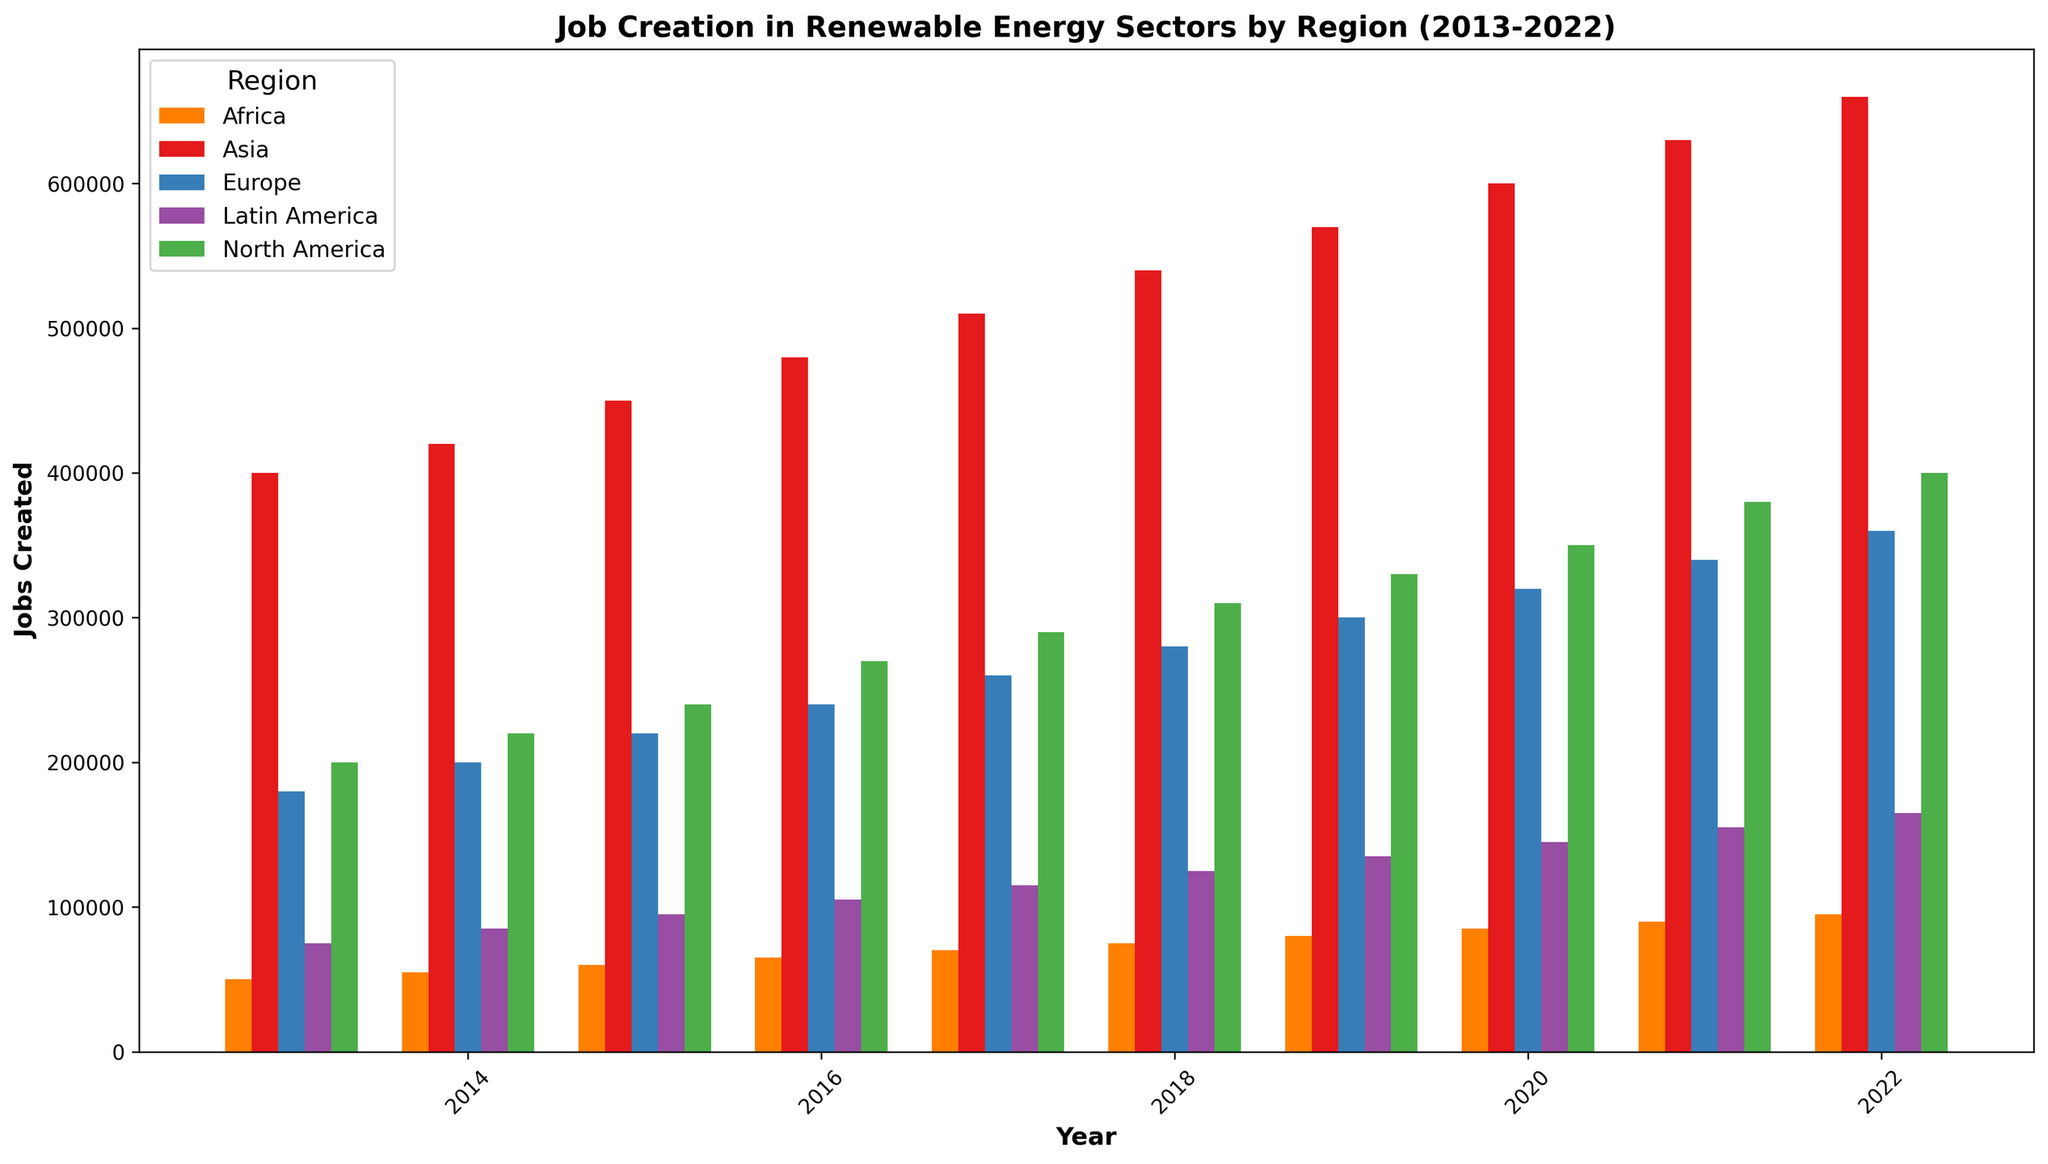What is the region with the highest number of jobs created in 2022? The figure shows job creation data for different regions, with each region represented by differently colored bars. Identify the tallest bar for the year 2022 to find the region with the highest job creation. The tallest bar in 2022 corresponds to Asia.
Answer: Asia Which region experienced the largest increase in job creation from 2013 to 2022? By comparing the heights of bars from 2013 to 2022 for each region, you can calculate the increase by subtracting the height of the 2013 bar from the height of the 2022 bar. Asia has the largest increase in job creation from 400,000 in 2013 to 660,000 in 2022, an increase of 260,000.
Answer: Asia How many more jobs were created in North America compared to Latin America in 2022? Look at the bars representing North America and Latin America in 2022. North America's bar reaches 400,000 jobs and Latin America's bar reaches 165,000 jobs. Subtract Latin America's job creation from North America's: 400,000 - 165,000 = 235,000 more jobs in North America.
Answer: 235,000 Rank the regions based on the number of jobs created in 2017 from highest to lowest. For the year 2017, check the heights of the bars for each region. Asia has the highest jobs (510,000), followed by North America (290,000), Europe (260,000), Latin America (115,000), and Africa (70,000). So, the ranking is Asia, North America, Europe, Latin America, Africa.
Answer: Asia, North America, Europe, Latin America, Africa What is the average number of jobs created in Europe from 2013 to 2022? To determine the average, sum the job creation numbers for Europe over the years 2013 to 2022 and then divide by the number of years. Summing all the values gives (180000 + 200000 + 220000 + 240000 + 260000 + 280000 + 300000 + 320000 + 340000 + 360000) = 2700000. Dividing by the 10 years gives an average of 2700000 / 10 = 270,000.
Answer: 270,000 Which year shows the smallest difference in job creation between North America and Europe? Calculate the differences in job creation between North America and Europe for each year by subtracting Europe’s job creation numbers from North America's. The year with the smallest absolute difference is 2013 with North America at 200,000 and Europe at 180,000:
Answer: 2013 Among all the regions, which one shows the least number of jobs created in 2015? Look at the bars for the year 2015 for all regions and identify the shortest one. Africa's bar for 2015 is the shortest, showing 60,000 jobs created.
Answer: Africa How does the job creation trend in Africa from 2013 to 2022 compare to that in Asia? Observe the length of bars representing Africa and Asia from 2013 to 2022. While both regions show an upward trend, Asia's increase is substantially larger (from 400,000 to 660,000) compared to Africa's steady yet smaller increase (from 50,000 to 95,000).
Answer: Asia shows a significantly larger increase What is the total number of jobs created across all regions in 2020? Sum the bar heights for all regions in 2020. For 2020, North America (350,000) + Europe (320,000) + Asia (600,000) + Africa (85,000) + Latin America (145,000) gives a total of 1,500,000 jobs.
Answer: 1,500,000 